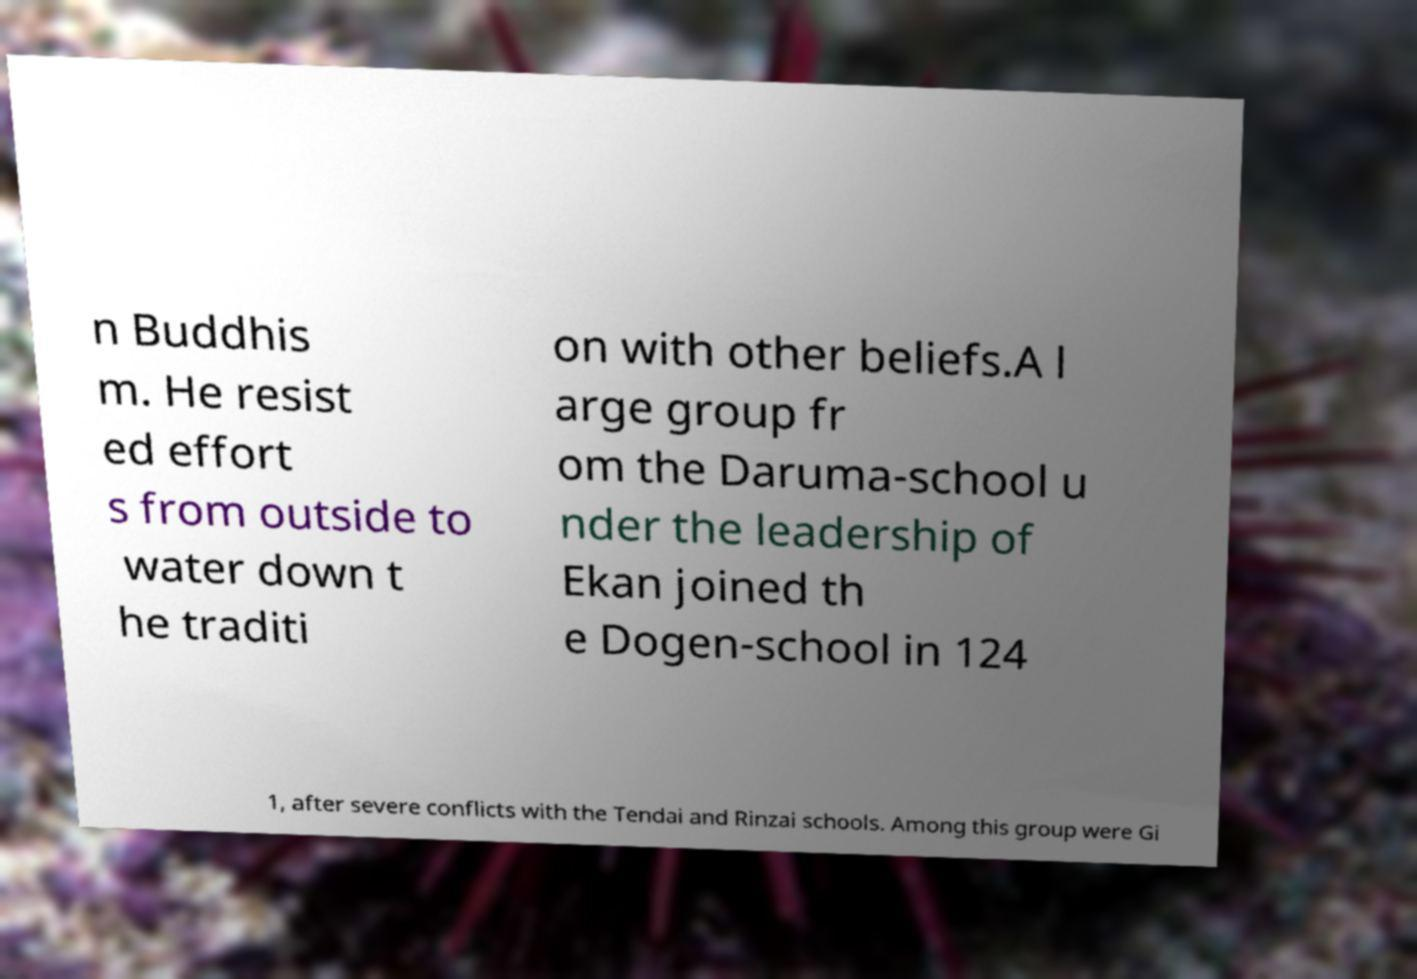Can you read and provide the text displayed in the image?This photo seems to have some interesting text. Can you extract and type it out for me? n Buddhis m. He resist ed effort s from outside to water down t he traditi on with other beliefs.A l arge group fr om the Daruma-school u nder the leadership of Ekan joined th e Dogen-school in 124 1, after severe conflicts with the Tendai and Rinzai schools. Among this group were Gi 